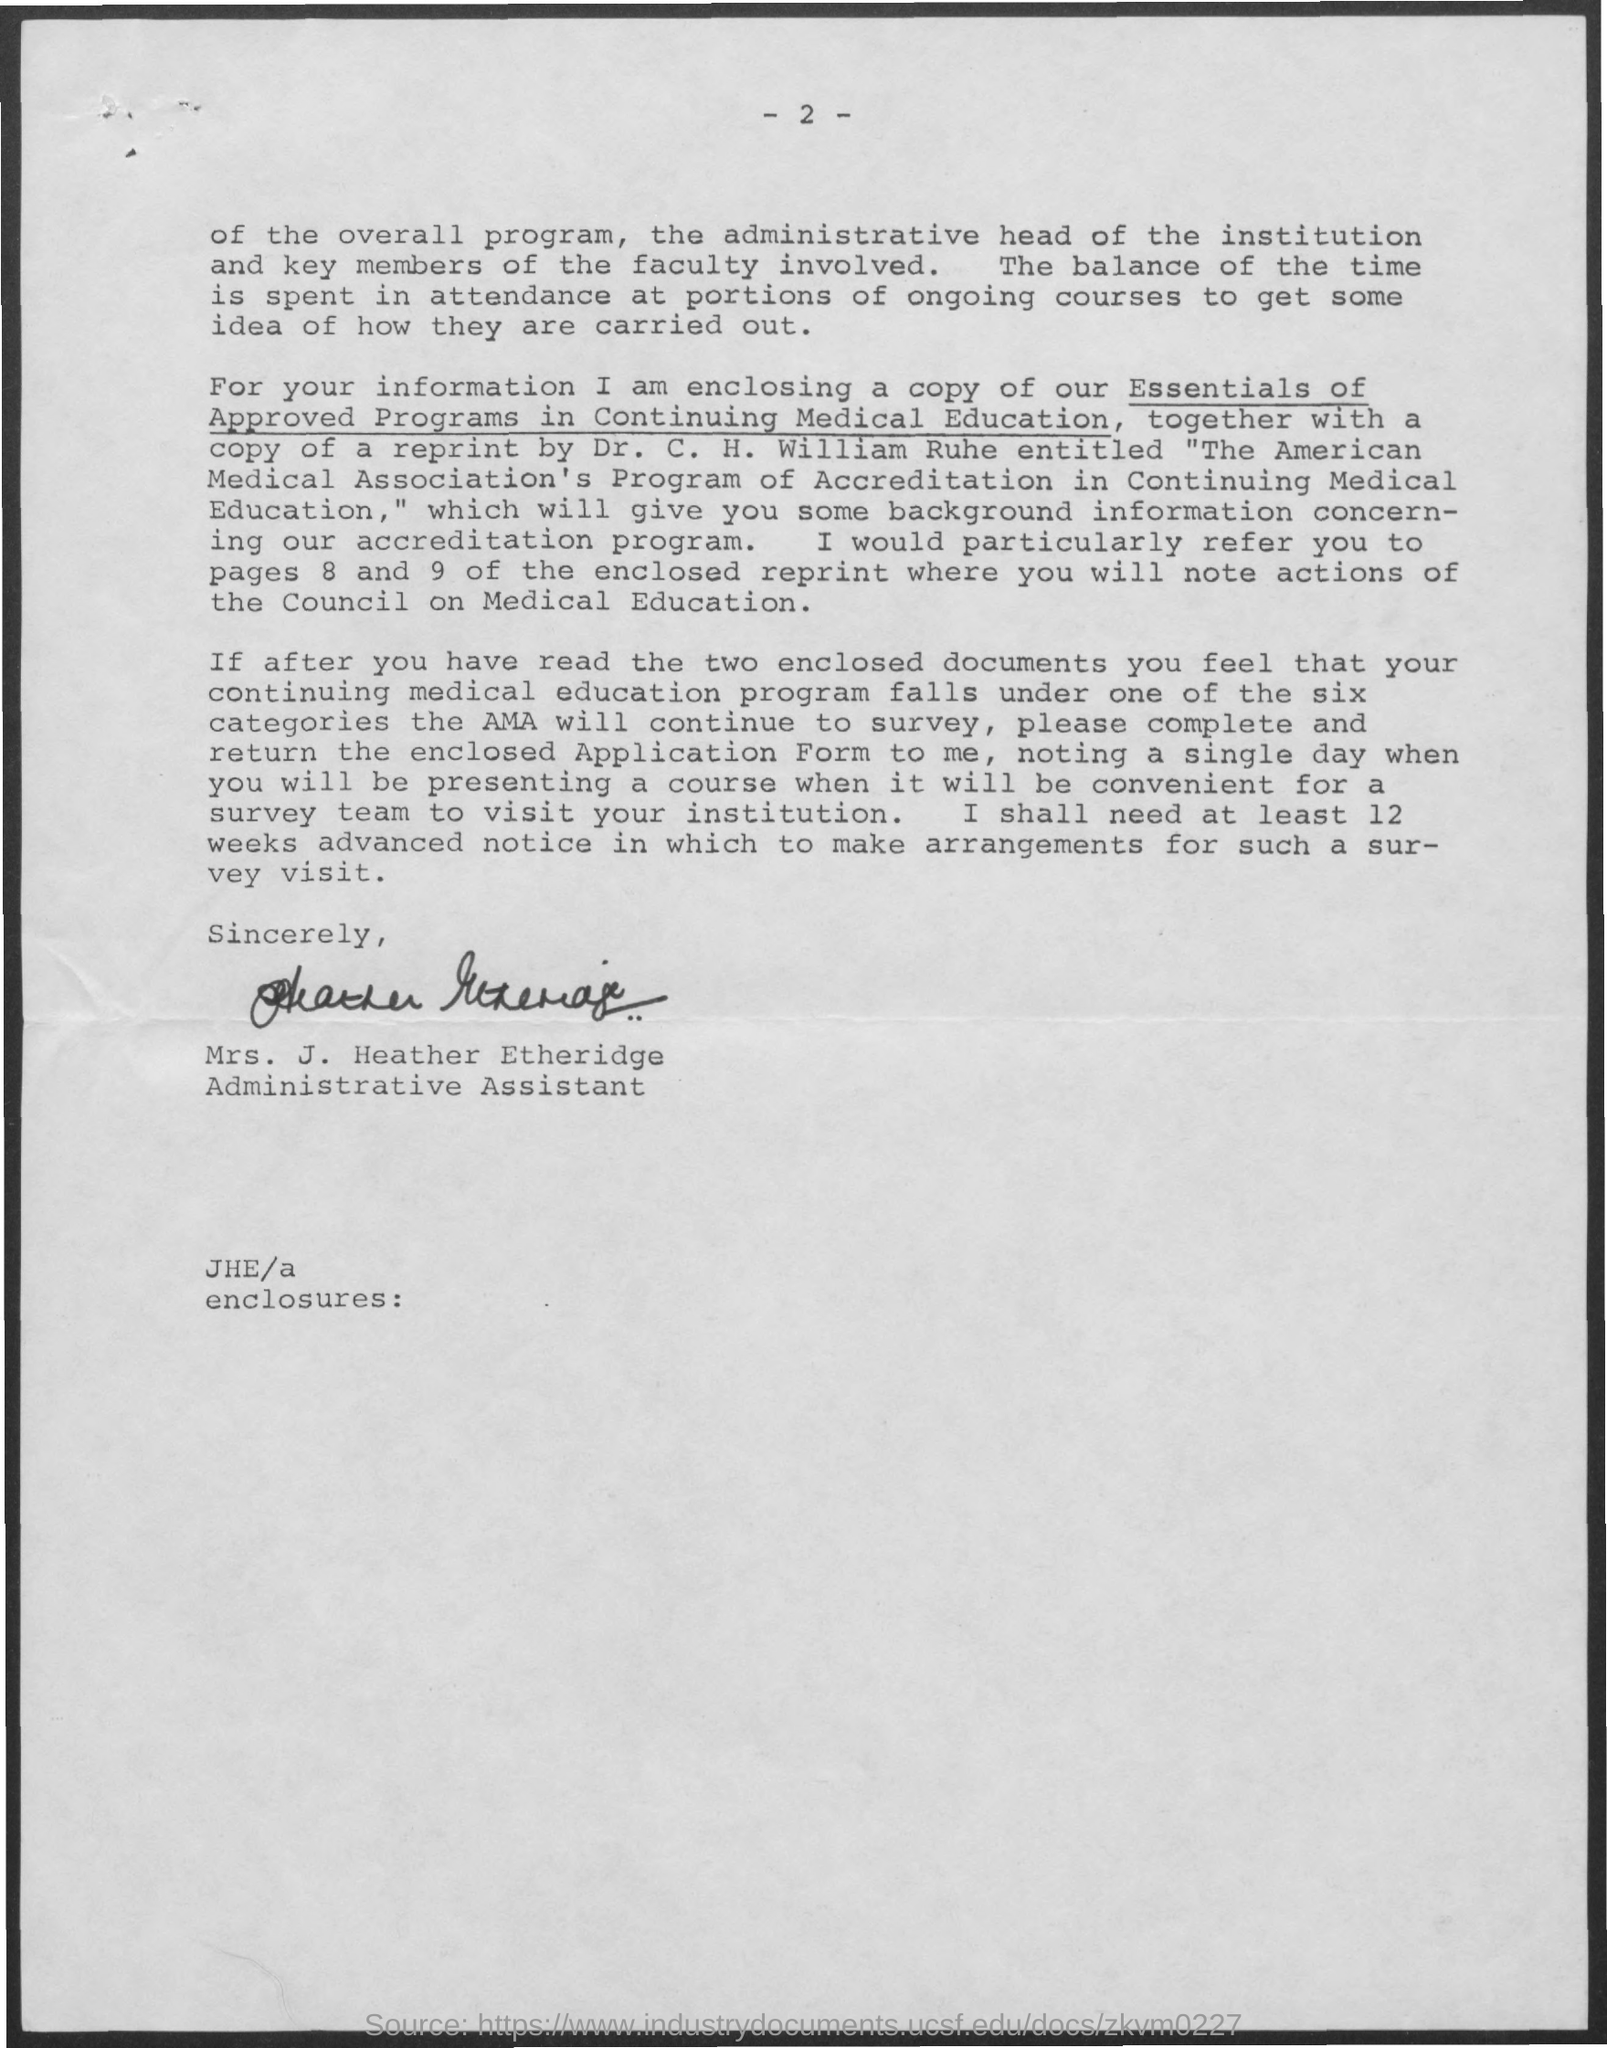Who has signed this document?
Your answer should be compact. Mrs. J. Heather Etheridge. What is the page no mentioned in this document?
Offer a very short reply. - 2 -. What is the designation of Mrs. J. Heather Etheridge?
Provide a succinct answer. Administrative Assistant. 